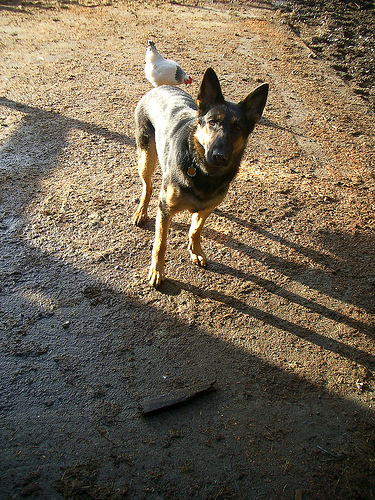<image>
Is there a bird on the dog? No. The bird is not positioned on the dog. They may be near each other, but the bird is not supported by or resting on top of the dog. 